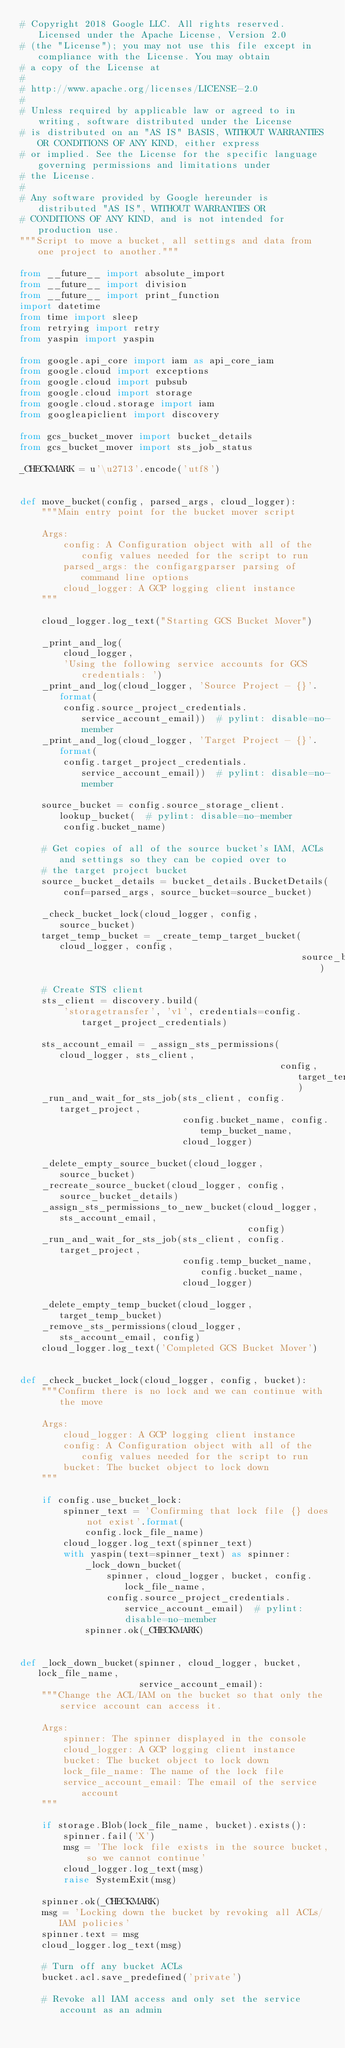<code> <loc_0><loc_0><loc_500><loc_500><_Python_># Copyright 2018 Google LLC. All rights reserved. Licensed under the Apache License, Version 2.0
# (the "License"); you may not use this file except in compliance with the License. You may obtain
# a copy of the License at
#
# http://www.apache.org/licenses/LICENSE-2.0
#
# Unless required by applicable law or agreed to in writing, software distributed under the License
# is distributed on an "AS IS" BASIS, WITHOUT WARRANTIES OR CONDITIONS OF ANY KIND, either express
# or implied. See the License for the specific language governing permissions and limitations under
# the License.
#
# Any software provided by Google hereunder is distributed "AS IS", WITHOUT WARRANTIES OR
# CONDITIONS OF ANY KIND, and is not intended for production use.
"""Script to move a bucket, all settings and data from one project to another."""

from __future__ import absolute_import
from __future__ import division
from __future__ import print_function
import datetime
from time import sleep
from retrying import retry
from yaspin import yaspin

from google.api_core import iam as api_core_iam
from google.cloud import exceptions
from google.cloud import pubsub
from google.cloud import storage
from google.cloud.storage import iam
from googleapiclient import discovery

from gcs_bucket_mover import bucket_details
from gcs_bucket_mover import sts_job_status

_CHECKMARK = u'\u2713'.encode('utf8')


def move_bucket(config, parsed_args, cloud_logger):
    """Main entry point for the bucket mover script

    Args:
        config: A Configuration object with all of the config values needed for the script to run
        parsed_args: the configargparser parsing of command line options
        cloud_logger: A GCP logging client instance
    """

    cloud_logger.log_text("Starting GCS Bucket Mover")

    _print_and_log(
        cloud_logger,
        'Using the following service accounts for GCS credentials: ')
    _print_and_log(cloud_logger, 'Source Project - {}'.format(
        config.source_project_credentials.service_account_email))  # pylint: disable=no-member
    _print_and_log(cloud_logger, 'Target Project - {}'.format(
        config.target_project_credentials.service_account_email))  # pylint: disable=no-member

    source_bucket = config.source_storage_client.lookup_bucket(  # pylint: disable=no-member
        config.bucket_name)

    # Get copies of all of the source bucket's IAM, ACLs and settings so they can be copied over to
    # the target project bucket
    source_bucket_details = bucket_details.BucketDetails(
        conf=parsed_args, source_bucket=source_bucket)

    _check_bucket_lock(cloud_logger, config, source_bucket)
    target_temp_bucket = _create_temp_target_bucket(cloud_logger, config,
                                                    source_bucket_details)

    # Create STS client
    sts_client = discovery.build(
        'storagetransfer', 'v1', credentials=config.target_project_credentials)

    sts_account_email = _assign_sts_permissions(cloud_logger, sts_client,
                                                config, target_temp_bucket)
    _run_and_wait_for_sts_job(sts_client, config.target_project,
                              config.bucket_name, config.temp_bucket_name,
                              cloud_logger)

    _delete_empty_source_bucket(cloud_logger, source_bucket)
    _recreate_source_bucket(cloud_logger, config, source_bucket_details)
    _assign_sts_permissions_to_new_bucket(cloud_logger, sts_account_email,
                                          config)
    _run_and_wait_for_sts_job(sts_client, config.target_project,
                              config.temp_bucket_name, config.bucket_name,
                              cloud_logger)

    _delete_empty_temp_bucket(cloud_logger, target_temp_bucket)
    _remove_sts_permissions(cloud_logger, sts_account_email, config)
    cloud_logger.log_text('Completed GCS Bucket Mover')


def _check_bucket_lock(cloud_logger, config, bucket):
    """Confirm there is no lock and we can continue with the move

    Args:
        cloud_logger: A GCP logging client instance
        config: A Configuration object with all of the config values needed for the script to run
        bucket: The bucket object to lock down
    """

    if config.use_bucket_lock:
        spinner_text = 'Confirming that lock file {} does not exist'.format(
            config.lock_file_name)
        cloud_logger.log_text(spinner_text)
        with yaspin(text=spinner_text) as spinner:
            _lock_down_bucket(
                spinner, cloud_logger, bucket, config.lock_file_name,
                config.source_project_credentials.service_account_email)  # pylint: disable=no-member
            spinner.ok(_CHECKMARK)


def _lock_down_bucket(spinner, cloud_logger, bucket, lock_file_name,
                      service_account_email):
    """Change the ACL/IAM on the bucket so that only the service account can access it.

    Args:
        spinner: The spinner displayed in the console
        cloud_logger: A GCP logging client instance
        bucket: The bucket object to lock down
        lock_file_name: The name of the lock file
        service_account_email: The email of the service account
    """

    if storage.Blob(lock_file_name, bucket).exists():
        spinner.fail('X')
        msg = 'The lock file exists in the source bucket, so we cannot continue'
        cloud_logger.log_text(msg)
        raise SystemExit(msg)

    spinner.ok(_CHECKMARK)
    msg = 'Locking down the bucket by revoking all ACLs/IAM policies'
    spinner.text = msg
    cloud_logger.log_text(msg)

    # Turn off any bucket ACLs
    bucket.acl.save_predefined('private')

    # Revoke all IAM access and only set the service account as an admin</code> 